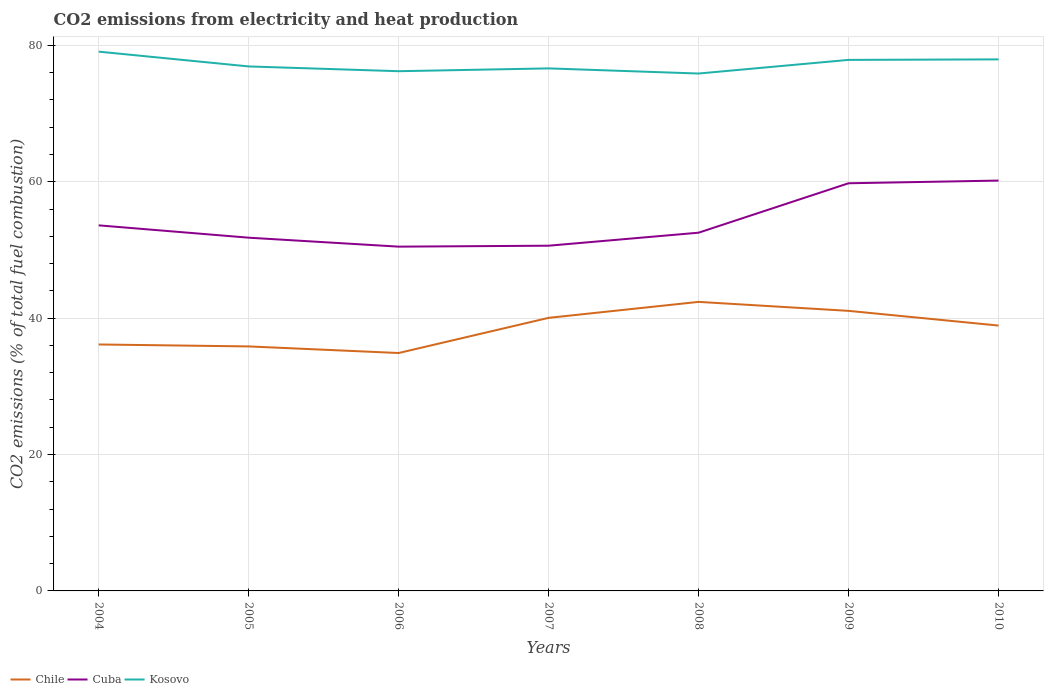How many different coloured lines are there?
Give a very brief answer. 3. Is the number of lines equal to the number of legend labels?
Ensure brevity in your answer.  Yes. Across all years, what is the maximum amount of CO2 emitted in Cuba?
Provide a short and direct response. 50.49. In which year was the amount of CO2 emitted in Cuba maximum?
Provide a succinct answer. 2006. What is the total amount of CO2 emitted in Chile in the graph?
Provide a short and direct response. 2.16. What is the difference between the highest and the second highest amount of CO2 emitted in Kosovo?
Your answer should be compact. 3.21. How many lines are there?
Provide a short and direct response. 3. Does the graph contain any zero values?
Keep it short and to the point. No. Does the graph contain grids?
Provide a short and direct response. Yes. How many legend labels are there?
Ensure brevity in your answer.  3. What is the title of the graph?
Your response must be concise. CO2 emissions from electricity and heat production. Does "Albania" appear as one of the legend labels in the graph?
Provide a short and direct response. No. What is the label or title of the Y-axis?
Keep it short and to the point. CO2 emissions (% of total fuel combustion). What is the CO2 emissions (% of total fuel combustion) of Chile in 2004?
Ensure brevity in your answer.  36.14. What is the CO2 emissions (% of total fuel combustion) in Cuba in 2004?
Your response must be concise. 53.61. What is the CO2 emissions (% of total fuel combustion) of Kosovo in 2004?
Keep it short and to the point. 79.08. What is the CO2 emissions (% of total fuel combustion) in Chile in 2005?
Your answer should be compact. 35.85. What is the CO2 emissions (% of total fuel combustion) in Cuba in 2005?
Make the answer very short. 51.8. What is the CO2 emissions (% of total fuel combustion) of Kosovo in 2005?
Give a very brief answer. 76.91. What is the CO2 emissions (% of total fuel combustion) of Chile in 2006?
Give a very brief answer. 34.89. What is the CO2 emissions (% of total fuel combustion) of Cuba in 2006?
Offer a terse response. 50.49. What is the CO2 emissions (% of total fuel combustion) of Kosovo in 2006?
Give a very brief answer. 76.21. What is the CO2 emissions (% of total fuel combustion) in Chile in 2007?
Offer a very short reply. 40.04. What is the CO2 emissions (% of total fuel combustion) of Cuba in 2007?
Offer a very short reply. 50.62. What is the CO2 emissions (% of total fuel combustion) in Kosovo in 2007?
Make the answer very short. 76.62. What is the CO2 emissions (% of total fuel combustion) in Chile in 2008?
Give a very brief answer. 42.38. What is the CO2 emissions (% of total fuel combustion) of Cuba in 2008?
Make the answer very short. 52.53. What is the CO2 emissions (% of total fuel combustion) of Kosovo in 2008?
Offer a very short reply. 75.87. What is the CO2 emissions (% of total fuel combustion) in Chile in 2009?
Make the answer very short. 41.07. What is the CO2 emissions (% of total fuel combustion) of Cuba in 2009?
Keep it short and to the point. 59.78. What is the CO2 emissions (% of total fuel combustion) in Kosovo in 2009?
Make the answer very short. 77.87. What is the CO2 emissions (% of total fuel combustion) of Chile in 2010?
Provide a short and direct response. 38.91. What is the CO2 emissions (% of total fuel combustion) of Cuba in 2010?
Your answer should be very brief. 60.17. What is the CO2 emissions (% of total fuel combustion) in Kosovo in 2010?
Offer a very short reply. 77.95. Across all years, what is the maximum CO2 emissions (% of total fuel combustion) of Chile?
Give a very brief answer. 42.38. Across all years, what is the maximum CO2 emissions (% of total fuel combustion) in Cuba?
Provide a short and direct response. 60.17. Across all years, what is the maximum CO2 emissions (% of total fuel combustion) of Kosovo?
Ensure brevity in your answer.  79.08. Across all years, what is the minimum CO2 emissions (% of total fuel combustion) in Chile?
Your response must be concise. 34.89. Across all years, what is the minimum CO2 emissions (% of total fuel combustion) in Cuba?
Keep it short and to the point. 50.49. Across all years, what is the minimum CO2 emissions (% of total fuel combustion) of Kosovo?
Offer a terse response. 75.87. What is the total CO2 emissions (% of total fuel combustion) of Chile in the graph?
Your answer should be compact. 269.29. What is the total CO2 emissions (% of total fuel combustion) in Cuba in the graph?
Ensure brevity in your answer.  379. What is the total CO2 emissions (% of total fuel combustion) of Kosovo in the graph?
Offer a terse response. 540.52. What is the difference between the CO2 emissions (% of total fuel combustion) in Chile in 2004 and that in 2005?
Ensure brevity in your answer.  0.29. What is the difference between the CO2 emissions (% of total fuel combustion) in Cuba in 2004 and that in 2005?
Give a very brief answer. 1.81. What is the difference between the CO2 emissions (% of total fuel combustion) in Kosovo in 2004 and that in 2005?
Provide a succinct answer. 2.17. What is the difference between the CO2 emissions (% of total fuel combustion) of Chile in 2004 and that in 2006?
Provide a succinct answer. 1.25. What is the difference between the CO2 emissions (% of total fuel combustion) in Cuba in 2004 and that in 2006?
Your response must be concise. 3.12. What is the difference between the CO2 emissions (% of total fuel combustion) of Kosovo in 2004 and that in 2006?
Give a very brief answer. 2.87. What is the difference between the CO2 emissions (% of total fuel combustion) in Chile in 2004 and that in 2007?
Keep it short and to the point. -3.9. What is the difference between the CO2 emissions (% of total fuel combustion) of Cuba in 2004 and that in 2007?
Ensure brevity in your answer.  2.98. What is the difference between the CO2 emissions (% of total fuel combustion) in Kosovo in 2004 and that in 2007?
Ensure brevity in your answer.  2.46. What is the difference between the CO2 emissions (% of total fuel combustion) of Chile in 2004 and that in 2008?
Your response must be concise. -6.24. What is the difference between the CO2 emissions (% of total fuel combustion) of Cuba in 2004 and that in 2008?
Give a very brief answer. 1.08. What is the difference between the CO2 emissions (% of total fuel combustion) in Kosovo in 2004 and that in 2008?
Keep it short and to the point. 3.21. What is the difference between the CO2 emissions (% of total fuel combustion) of Chile in 2004 and that in 2009?
Your answer should be very brief. -4.93. What is the difference between the CO2 emissions (% of total fuel combustion) in Cuba in 2004 and that in 2009?
Provide a succinct answer. -6.17. What is the difference between the CO2 emissions (% of total fuel combustion) in Kosovo in 2004 and that in 2009?
Give a very brief answer. 1.21. What is the difference between the CO2 emissions (% of total fuel combustion) in Chile in 2004 and that in 2010?
Offer a very short reply. -2.77. What is the difference between the CO2 emissions (% of total fuel combustion) of Cuba in 2004 and that in 2010?
Make the answer very short. -6.57. What is the difference between the CO2 emissions (% of total fuel combustion) of Kosovo in 2004 and that in 2010?
Keep it short and to the point. 1.13. What is the difference between the CO2 emissions (% of total fuel combustion) in Cuba in 2005 and that in 2006?
Your answer should be compact. 1.31. What is the difference between the CO2 emissions (% of total fuel combustion) in Kosovo in 2005 and that in 2006?
Provide a short and direct response. 0.7. What is the difference between the CO2 emissions (% of total fuel combustion) in Chile in 2005 and that in 2007?
Provide a succinct answer. -4.19. What is the difference between the CO2 emissions (% of total fuel combustion) in Cuba in 2005 and that in 2007?
Give a very brief answer. 1.18. What is the difference between the CO2 emissions (% of total fuel combustion) in Kosovo in 2005 and that in 2007?
Provide a succinct answer. 0.29. What is the difference between the CO2 emissions (% of total fuel combustion) in Chile in 2005 and that in 2008?
Offer a terse response. -6.53. What is the difference between the CO2 emissions (% of total fuel combustion) in Cuba in 2005 and that in 2008?
Offer a very short reply. -0.73. What is the difference between the CO2 emissions (% of total fuel combustion) in Kosovo in 2005 and that in 2008?
Provide a short and direct response. 1.04. What is the difference between the CO2 emissions (% of total fuel combustion) in Chile in 2005 and that in 2009?
Provide a short and direct response. -5.21. What is the difference between the CO2 emissions (% of total fuel combustion) of Cuba in 2005 and that in 2009?
Provide a short and direct response. -7.98. What is the difference between the CO2 emissions (% of total fuel combustion) of Kosovo in 2005 and that in 2009?
Give a very brief answer. -0.96. What is the difference between the CO2 emissions (% of total fuel combustion) of Chile in 2005 and that in 2010?
Make the answer very short. -3.06. What is the difference between the CO2 emissions (% of total fuel combustion) of Cuba in 2005 and that in 2010?
Provide a succinct answer. -8.37. What is the difference between the CO2 emissions (% of total fuel combustion) in Kosovo in 2005 and that in 2010?
Keep it short and to the point. -1.03. What is the difference between the CO2 emissions (% of total fuel combustion) in Chile in 2006 and that in 2007?
Your answer should be compact. -5.16. What is the difference between the CO2 emissions (% of total fuel combustion) of Cuba in 2006 and that in 2007?
Ensure brevity in your answer.  -0.14. What is the difference between the CO2 emissions (% of total fuel combustion) in Kosovo in 2006 and that in 2007?
Provide a succinct answer. -0.41. What is the difference between the CO2 emissions (% of total fuel combustion) of Chile in 2006 and that in 2008?
Offer a terse response. -7.5. What is the difference between the CO2 emissions (% of total fuel combustion) of Cuba in 2006 and that in 2008?
Give a very brief answer. -2.04. What is the difference between the CO2 emissions (% of total fuel combustion) of Kosovo in 2006 and that in 2008?
Provide a short and direct response. 0.34. What is the difference between the CO2 emissions (% of total fuel combustion) of Chile in 2006 and that in 2009?
Provide a succinct answer. -6.18. What is the difference between the CO2 emissions (% of total fuel combustion) in Cuba in 2006 and that in 2009?
Provide a succinct answer. -9.29. What is the difference between the CO2 emissions (% of total fuel combustion) of Kosovo in 2006 and that in 2009?
Your response must be concise. -1.66. What is the difference between the CO2 emissions (% of total fuel combustion) in Chile in 2006 and that in 2010?
Offer a terse response. -4.03. What is the difference between the CO2 emissions (% of total fuel combustion) of Cuba in 2006 and that in 2010?
Offer a terse response. -9.69. What is the difference between the CO2 emissions (% of total fuel combustion) of Kosovo in 2006 and that in 2010?
Provide a short and direct response. -1.73. What is the difference between the CO2 emissions (% of total fuel combustion) of Chile in 2007 and that in 2008?
Keep it short and to the point. -2.34. What is the difference between the CO2 emissions (% of total fuel combustion) in Cuba in 2007 and that in 2008?
Make the answer very short. -1.91. What is the difference between the CO2 emissions (% of total fuel combustion) in Kosovo in 2007 and that in 2008?
Provide a succinct answer. 0.75. What is the difference between the CO2 emissions (% of total fuel combustion) in Chile in 2007 and that in 2009?
Offer a terse response. -1.03. What is the difference between the CO2 emissions (% of total fuel combustion) in Cuba in 2007 and that in 2009?
Offer a terse response. -9.16. What is the difference between the CO2 emissions (% of total fuel combustion) in Kosovo in 2007 and that in 2009?
Offer a terse response. -1.25. What is the difference between the CO2 emissions (% of total fuel combustion) of Chile in 2007 and that in 2010?
Your answer should be very brief. 1.13. What is the difference between the CO2 emissions (% of total fuel combustion) of Cuba in 2007 and that in 2010?
Your answer should be very brief. -9.55. What is the difference between the CO2 emissions (% of total fuel combustion) in Kosovo in 2007 and that in 2010?
Provide a short and direct response. -1.32. What is the difference between the CO2 emissions (% of total fuel combustion) of Chile in 2008 and that in 2009?
Ensure brevity in your answer.  1.32. What is the difference between the CO2 emissions (% of total fuel combustion) in Cuba in 2008 and that in 2009?
Ensure brevity in your answer.  -7.25. What is the difference between the CO2 emissions (% of total fuel combustion) of Kosovo in 2008 and that in 2009?
Ensure brevity in your answer.  -2. What is the difference between the CO2 emissions (% of total fuel combustion) in Chile in 2008 and that in 2010?
Your answer should be compact. 3.47. What is the difference between the CO2 emissions (% of total fuel combustion) in Cuba in 2008 and that in 2010?
Your answer should be compact. -7.64. What is the difference between the CO2 emissions (% of total fuel combustion) of Kosovo in 2008 and that in 2010?
Offer a very short reply. -2.08. What is the difference between the CO2 emissions (% of total fuel combustion) of Chile in 2009 and that in 2010?
Your response must be concise. 2.16. What is the difference between the CO2 emissions (% of total fuel combustion) in Cuba in 2009 and that in 2010?
Your answer should be very brief. -0.4. What is the difference between the CO2 emissions (% of total fuel combustion) in Kosovo in 2009 and that in 2010?
Make the answer very short. -0.07. What is the difference between the CO2 emissions (% of total fuel combustion) of Chile in 2004 and the CO2 emissions (% of total fuel combustion) of Cuba in 2005?
Offer a terse response. -15.66. What is the difference between the CO2 emissions (% of total fuel combustion) of Chile in 2004 and the CO2 emissions (% of total fuel combustion) of Kosovo in 2005?
Ensure brevity in your answer.  -40.77. What is the difference between the CO2 emissions (% of total fuel combustion) in Cuba in 2004 and the CO2 emissions (% of total fuel combustion) in Kosovo in 2005?
Provide a short and direct response. -23.3. What is the difference between the CO2 emissions (% of total fuel combustion) in Chile in 2004 and the CO2 emissions (% of total fuel combustion) in Cuba in 2006?
Offer a terse response. -14.35. What is the difference between the CO2 emissions (% of total fuel combustion) in Chile in 2004 and the CO2 emissions (% of total fuel combustion) in Kosovo in 2006?
Provide a short and direct response. -40.07. What is the difference between the CO2 emissions (% of total fuel combustion) of Cuba in 2004 and the CO2 emissions (% of total fuel combustion) of Kosovo in 2006?
Offer a very short reply. -22.6. What is the difference between the CO2 emissions (% of total fuel combustion) in Chile in 2004 and the CO2 emissions (% of total fuel combustion) in Cuba in 2007?
Provide a succinct answer. -14.48. What is the difference between the CO2 emissions (% of total fuel combustion) in Chile in 2004 and the CO2 emissions (% of total fuel combustion) in Kosovo in 2007?
Your response must be concise. -40.48. What is the difference between the CO2 emissions (% of total fuel combustion) of Cuba in 2004 and the CO2 emissions (% of total fuel combustion) of Kosovo in 2007?
Your response must be concise. -23.02. What is the difference between the CO2 emissions (% of total fuel combustion) of Chile in 2004 and the CO2 emissions (% of total fuel combustion) of Cuba in 2008?
Give a very brief answer. -16.39. What is the difference between the CO2 emissions (% of total fuel combustion) in Chile in 2004 and the CO2 emissions (% of total fuel combustion) in Kosovo in 2008?
Provide a short and direct response. -39.73. What is the difference between the CO2 emissions (% of total fuel combustion) in Cuba in 2004 and the CO2 emissions (% of total fuel combustion) in Kosovo in 2008?
Give a very brief answer. -22.26. What is the difference between the CO2 emissions (% of total fuel combustion) in Chile in 2004 and the CO2 emissions (% of total fuel combustion) in Cuba in 2009?
Your answer should be very brief. -23.64. What is the difference between the CO2 emissions (% of total fuel combustion) of Chile in 2004 and the CO2 emissions (% of total fuel combustion) of Kosovo in 2009?
Provide a short and direct response. -41.73. What is the difference between the CO2 emissions (% of total fuel combustion) of Cuba in 2004 and the CO2 emissions (% of total fuel combustion) of Kosovo in 2009?
Your answer should be compact. -24.26. What is the difference between the CO2 emissions (% of total fuel combustion) in Chile in 2004 and the CO2 emissions (% of total fuel combustion) in Cuba in 2010?
Your answer should be compact. -24.03. What is the difference between the CO2 emissions (% of total fuel combustion) in Chile in 2004 and the CO2 emissions (% of total fuel combustion) in Kosovo in 2010?
Provide a short and direct response. -41.81. What is the difference between the CO2 emissions (% of total fuel combustion) in Cuba in 2004 and the CO2 emissions (% of total fuel combustion) in Kosovo in 2010?
Make the answer very short. -24.34. What is the difference between the CO2 emissions (% of total fuel combustion) in Chile in 2005 and the CO2 emissions (% of total fuel combustion) in Cuba in 2006?
Offer a terse response. -14.63. What is the difference between the CO2 emissions (% of total fuel combustion) of Chile in 2005 and the CO2 emissions (% of total fuel combustion) of Kosovo in 2006?
Make the answer very short. -40.36. What is the difference between the CO2 emissions (% of total fuel combustion) of Cuba in 2005 and the CO2 emissions (% of total fuel combustion) of Kosovo in 2006?
Your response must be concise. -24.41. What is the difference between the CO2 emissions (% of total fuel combustion) of Chile in 2005 and the CO2 emissions (% of total fuel combustion) of Cuba in 2007?
Offer a terse response. -14.77. What is the difference between the CO2 emissions (% of total fuel combustion) of Chile in 2005 and the CO2 emissions (% of total fuel combustion) of Kosovo in 2007?
Keep it short and to the point. -40.77. What is the difference between the CO2 emissions (% of total fuel combustion) in Cuba in 2005 and the CO2 emissions (% of total fuel combustion) in Kosovo in 2007?
Your answer should be compact. -24.82. What is the difference between the CO2 emissions (% of total fuel combustion) of Chile in 2005 and the CO2 emissions (% of total fuel combustion) of Cuba in 2008?
Provide a succinct answer. -16.68. What is the difference between the CO2 emissions (% of total fuel combustion) of Chile in 2005 and the CO2 emissions (% of total fuel combustion) of Kosovo in 2008?
Make the answer very short. -40.02. What is the difference between the CO2 emissions (% of total fuel combustion) in Cuba in 2005 and the CO2 emissions (% of total fuel combustion) in Kosovo in 2008?
Provide a short and direct response. -24.07. What is the difference between the CO2 emissions (% of total fuel combustion) of Chile in 2005 and the CO2 emissions (% of total fuel combustion) of Cuba in 2009?
Your answer should be compact. -23.92. What is the difference between the CO2 emissions (% of total fuel combustion) in Chile in 2005 and the CO2 emissions (% of total fuel combustion) in Kosovo in 2009?
Your response must be concise. -42.02. What is the difference between the CO2 emissions (% of total fuel combustion) in Cuba in 2005 and the CO2 emissions (% of total fuel combustion) in Kosovo in 2009?
Give a very brief answer. -26.07. What is the difference between the CO2 emissions (% of total fuel combustion) of Chile in 2005 and the CO2 emissions (% of total fuel combustion) of Cuba in 2010?
Your answer should be compact. -24.32. What is the difference between the CO2 emissions (% of total fuel combustion) of Chile in 2005 and the CO2 emissions (% of total fuel combustion) of Kosovo in 2010?
Your response must be concise. -42.09. What is the difference between the CO2 emissions (% of total fuel combustion) of Cuba in 2005 and the CO2 emissions (% of total fuel combustion) of Kosovo in 2010?
Your answer should be compact. -26.15. What is the difference between the CO2 emissions (% of total fuel combustion) in Chile in 2006 and the CO2 emissions (% of total fuel combustion) in Cuba in 2007?
Your response must be concise. -15.74. What is the difference between the CO2 emissions (% of total fuel combustion) in Chile in 2006 and the CO2 emissions (% of total fuel combustion) in Kosovo in 2007?
Offer a terse response. -41.74. What is the difference between the CO2 emissions (% of total fuel combustion) in Cuba in 2006 and the CO2 emissions (% of total fuel combustion) in Kosovo in 2007?
Provide a short and direct response. -26.14. What is the difference between the CO2 emissions (% of total fuel combustion) in Chile in 2006 and the CO2 emissions (% of total fuel combustion) in Cuba in 2008?
Make the answer very short. -17.64. What is the difference between the CO2 emissions (% of total fuel combustion) in Chile in 2006 and the CO2 emissions (% of total fuel combustion) in Kosovo in 2008?
Offer a very short reply. -40.98. What is the difference between the CO2 emissions (% of total fuel combustion) in Cuba in 2006 and the CO2 emissions (% of total fuel combustion) in Kosovo in 2008?
Your answer should be very brief. -25.39. What is the difference between the CO2 emissions (% of total fuel combustion) of Chile in 2006 and the CO2 emissions (% of total fuel combustion) of Cuba in 2009?
Make the answer very short. -24.89. What is the difference between the CO2 emissions (% of total fuel combustion) of Chile in 2006 and the CO2 emissions (% of total fuel combustion) of Kosovo in 2009?
Make the answer very short. -42.98. What is the difference between the CO2 emissions (% of total fuel combustion) in Cuba in 2006 and the CO2 emissions (% of total fuel combustion) in Kosovo in 2009?
Provide a succinct answer. -27.39. What is the difference between the CO2 emissions (% of total fuel combustion) of Chile in 2006 and the CO2 emissions (% of total fuel combustion) of Cuba in 2010?
Keep it short and to the point. -25.29. What is the difference between the CO2 emissions (% of total fuel combustion) in Chile in 2006 and the CO2 emissions (% of total fuel combustion) in Kosovo in 2010?
Make the answer very short. -43.06. What is the difference between the CO2 emissions (% of total fuel combustion) in Cuba in 2006 and the CO2 emissions (% of total fuel combustion) in Kosovo in 2010?
Your response must be concise. -27.46. What is the difference between the CO2 emissions (% of total fuel combustion) in Chile in 2007 and the CO2 emissions (% of total fuel combustion) in Cuba in 2008?
Make the answer very short. -12.49. What is the difference between the CO2 emissions (% of total fuel combustion) in Chile in 2007 and the CO2 emissions (% of total fuel combustion) in Kosovo in 2008?
Provide a succinct answer. -35.83. What is the difference between the CO2 emissions (% of total fuel combustion) in Cuba in 2007 and the CO2 emissions (% of total fuel combustion) in Kosovo in 2008?
Provide a short and direct response. -25.25. What is the difference between the CO2 emissions (% of total fuel combustion) in Chile in 2007 and the CO2 emissions (% of total fuel combustion) in Cuba in 2009?
Provide a short and direct response. -19.74. What is the difference between the CO2 emissions (% of total fuel combustion) of Chile in 2007 and the CO2 emissions (% of total fuel combustion) of Kosovo in 2009?
Provide a succinct answer. -37.83. What is the difference between the CO2 emissions (% of total fuel combustion) of Cuba in 2007 and the CO2 emissions (% of total fuel combustion) of Kosovo in 2009?
Provide a succinct answer. -27.25. What is the difference between the CO2 emissions (% of total fuel combustion) of Chile in 2007 and the CO2 emissions (% of total fuel combustion) of Cuba in 2010?
Your answer should be very brief. -20.13. What is the difference between the CO2 emissions (% of total fuel combustion) of Chile in 2007 and the CO2 emissions (% of total fuel combustion) of Kosovo in 2010?
Make the answer very short. -37.9. What is the difference between the CO2 emissions (% of total fuel combustion) in Cuba in 2007 and the CO2 emissions (% of total fuel combustion) in Kosovo in 2010?
Your answer should be compact. -27.32. What is the difference between the CO2 emissions (% of total fuel combustion) of Chile in 2008 and the CO2 emissions (% of total fuel combustion) of Cuba in 2009?
Provide a succinct answer. -17.39. What is the difference between the CO2 emissions (% of total fuel combustion) in Chile in 2008 and the CO2 emissions (% of total fuel combustion) in Kosovo in 2009?
Your answer should be compact. -35.49. What is the difference between the CO2 emissions (% of total fuel combustion) in Cuba in 2008 and the CO2 emissions (% of total fuel combustion) in Kosovo in 2009?
Make the answer very short. -25.34. What is the difference between the CO2 emissions (% of total fuel combustion) in Chile in 2008 and the CO2 emissions (% of total fuel combustion) in Cuba in 2010?
Ensure brevity in your answer.  -17.79. What is the difference between the CO2 emissions (% of total fuel combustion) of Chile in 2008 and the CO2 emissions (% of total fuel combustion) of Kosovo in 2010?
Your answer should be very brief. -35.56. What is the difference between the CO2 emissions (% of total fuel combustion) of Cuba in 2008 and the CO2 emissions (% of total fuel combustion) of Kosovo in 2010?
Provide a short and direct response. -25.42. What is the difference between the CO2 emissions (% of total fuel combustion) of Chile in 2009 and the CO2 emissions (% of total fuel combustion) of Cuba in 2010?
Make the answer very short. -19.1. What is the difference between the CO2 emissions (% of total fuel combustion) of Chile in 2009 and the CO2 emissions (% of total fuel combustion) of Kosovo in 2010?
Make the answer very short. -36.88. What is the difference between the CO2 emissions (% of total fuel combustion) in Cuba in 2009 and the CO2 emissions (% of total fuel combustion) in Kosovo in 2010?
Make the answer very short. -18.17. What is the average CO2 emissions (% of total fuel combustion) in Chile per year?
Your answer should be compact. 38.47. What is the average CO2 emissions (% of total fuel combustion) of Cuba per year?
Keep it short and to the point. 54.14. What is the average CO2 emissions (% of total fuel combustion) in Kosovo per year?
Make the answer very short. 77.22. In the year 2004, what is the difference between the CO2 emissions (% of total fuel combustion) of Chile and CO2 emissions (% of total fuel combustion) of Cuba?
Offer a very short reply. -17.47. In the year 2004, what is the difference between the CO2 emissions (% of total fuel combustion) of Chile and CO2 emissions (% of total fuel combustion) of Kosovo?
Your response must be concise. -42.94. In the year 2004, what is the difference between the CO2 emissions (% of total fuel combustion) of Cuba and CO2 emissions (% of total fuel combustion) of Kosovo?
Provide a short and direct response. -25.47. In the year 2005, what is the difference between the CO2 emissions (% of total fuel combustion) in Chile and CO2 emissions (% of total fuel combustion) in Cuba?
Keep it short and to the point. -15.94. In the year 2005, what is the difference between the CO2 emissions (% of total fuel combustion) of Chile and CO2 emissions (% of total fuel combustion) of Kosovo?
Make the answer very short. -41.06. In the year 2005, what is the difference between the CO2 emissions (% of total fuel combustion) of Cuba and CO2 emissions (% of total fuel combustion) of Kosovo?
Provide a succinct answer. -25.11. In the year 2006, what is the difference between the CO2 emissions (% of total fuel combustion) of Chile and CO2 emissions (% of total fuel combustion) of Cuba?
Your answer should be compact. -15.6. In the year 2006, what is the difference between the CO2 emissions (% of total fuel combustion) in Chile and CO2 emissions (% of total fuel combustion) in Kosovo?
Your answer should be very brief. -41.32. In the year 2006, what is the difference between the CO2 emissions (% of total fuel combustion) in Cuba and CO2 emissions (% of total fuel combustion) in Kosovo?
Ensure brevity in your answer.  -25.73. In the year 2007, what is the difference between the CO2 emissions (% of total fuel combustion) of Chile and CO2 emissions (% of total fuel combustion) of Cuba?
Offer a terse response. -10.58. In the year 2007, what is the difference between the CO2 emissions (% of total fuel combustion) in Chile and CO2 emissions (% of total fuel combustion) in Kosovo?
Your response must be concise. -36.58. In the year 2007, what is the difference between the CO2 emissions (% of total fuel combustion) in Cuba and CO2 emissions (% of total fuel combustion) in Kosovo?
Your answer should be compact. -26. In the year 2008, what is the difference between the CO2 emissions (% of total fuel combustion) of Chile and CO2 emissions (% of total fuel combustion) of Cuba?
Ensure brevity in your answer.  -10.15. In the year 2008, what is the difference between the CO2 emissions (% of total fuel combustion) of Chile and CO2 emissions (% of total fuel combustion) of Kosovo?
Give a very brief answer. -33.49. In the year 2008, what is the difference between the CO2 emissions (% of total fuel combustion) of Cuba and CO2 emissions (% of total fuel combustion) of Kosovo?
Offer a very short reply. -23.34. In the year 2009, what is the difference between the CO2 emissions (% of total fuel combustion) in Chile and CO2 emissions (% of total fuel combustion) in Cuba?
Your answer should be very brief. -18.71. In the year 2009, what is the difference between the CO2 emissions (% of total fuel combustion) in Chile and CO2 emissions (% of total fuel combustion) in Kosovo?
Offer a very short reply. -36.8. In the year 2009, what is the difference between the CO2 emissions (% of total fuel combustion) of Cuba and CO2 emissions (% of total fuel combustion) of Kosovo?
Offer a terse response. -18.09. In the year 2010, what is the difference between the CO2 emissions (% of total fuel combustion) in Chile and CO2 emissions (% of total fuel combustion) in Cuba?
Make the answer very short. -21.26. In the year 2010, what is the difference between the CO2 emissions (% of total fuel combustion) of Chile and CO2 emissions (% of total fuel combustion) of Kosovo?
Your response must be concise. -39.03. In the year 2010, what is the difference between the CO2 emissions (% of total fuel combustion) in Cuba and CO2 emissions (% of total fuel combustion) in Kosovo?
Your response must be concise. -17.77. What is the ratio of the CO2 emissions (% of total fuel combustion) of Chile in 2004 to that in 2005?
Make the answer very short. 1.01. What is the ratio of the CO2 emissions (% of total fuel combustion) in Cuba in 2004 to that in 2005?
Offer a terse response. 1.03. What is the ratio of the CO2 emissions (% of total fuel combustion) of Kosovo in 2004 to that in 2005?
Keep it short and to the point. 1.03. What is the ratio of the CO2 emissions (% of total fuel combustion) in Chile in 2004 to that in 2006?
Your answer should be compact. 1.04. What is the ratio of the CO2 emissions (% of total fuel combustion) of Cuba in 2004 to that in 2006?
Your response must be concise. 1.06. What is the ratio of the CO2 emissions (% of total fuel combustion) in Kosovo in 2004 to that in 2006?
Make the answer very short. 1.04. What is the ratio of the CO2 emissions (% of total fuel combustion) of Chile in 2004 to that in 2007?
Your response must be concise. 0.9. What is the ratio of the CO2 emissions (% of total fuel combustion) of Cuba in 2004 to that in 2007?
Keep it short and to the point. 1.06. What is the ratio of the CO2 emissions (% of total fuel combustion) in Kosovo in 2004 to that in 2007?
Provide a succinct answer. 1.03. What is the ratio of the CO2 emissions (% of total fuel combustion) in Chile in 2004 to that in 2008?
Provide a short and direct response. 0.85. What is the ratio of the CO2 emissions (% of total fuel combustion) in Cuba in 2004 to that in 2008?
Make the answer very short. 1.02. What is the ratio of the CO2 emissions (% of total fuel combustion) of Kosovo in 2004 to that in 2008?
Keep it short and to the point. 1.04. What is the ratio of the CO2 emissions (% of total fuel combustion) in Chile in 2004 to that in 2009?
Provide a short and direct response. 0.88. What is the ratio of the CO2 emissions (% of total fuel combustion) in Cuba in 2004 to that in 2009?
Provide a short and direct response. 0.9. What is the ratio of the CO2 emissions (% of total fuel combustion) of Kosovo in 2004 to that in 2009?
Offer a terse response. 1.02. What is the ratio of the CO2 emissions (% of total fuel combustion) in Chile in 2004 to that in 2010?
Give a very brief answer. 0.93. What is the ratio of the CO2 emissions (% of total fuel combustion) in Cuba in 2004 to that in 2010?
Your response must be concise. 0.89. What is the ratio of the CO2 emissions (% of total fuel combustion) of Kosovo in 2004 to that in 2010?
Offer a very short reply. 1.01. What is the ratio of the CO2 emissions (% of total fuel combustion) of Chile in 2005 to that in 2006?
Offer a very short reply. 1.03. What is the ratio of the CO2 emissions (% of total fuel combustion) of Cuba in 2005 to that in 2006?
Your answer should be very brief. 1.03. What is the ratio of the CO2 emissions (% of total fuel combustion) in Kosovo in 2005 to that in 2006?
Your response must be concise. 1.01. What is the ratio of the CO2 emissions (% of total fuel combustion) of Chile in 2005 to that in 2007?
Provide a short and direct response. 0.9. What is the ratio of the CO2 emissions (% of total fuel combustion) of Cuba in 2005 to that in 2007?
Offer a very short reply. 1.02. What is the ratio of the CO2 emissions (% of total fuel combustion) of Kosovo in 2005 to that in 2007?
Offer a very short reply. 1. What is the ratio of the CO2 emissions (% of total fuel combustion) in Chile in 2005 to that in 2008?
Your answer should be compact. 0.85. What is the ratio of the CO2 emissions (% of total fuel combustion) in Cuba in 2005 to that in 2008?
Keep it short and to the point. 0.99. What is the ratio of the CO2 emissions (% of total fuel combustion) in Kosovo in 2005 to that in 2008?
Give a very brief answer. 1.01. What is the ratio of the CO2 emissions (% of total fuel combustion) in Chile in 2005 to that in 2009?
Keep it short and to the point. 0.87. What is the ratio of the CO2 emissions (% of total fuel combustion) of Cuba in 2005 to that in 2009?
Your response must be concise. 0.87. What is the ratio of the CO2 emissions (% of total fuel combustion) in Kosovo in 2005 to that in 2009?
Offer a terse response. 0.99. What is the ratio of the CO2 emissions (% of total fuel combustion) of Chile in 2005 to that in 2010?
Make the answer very short. 0.92. What is the ratio of the CO2 emissions (% of total fuel combustion) in Cuba in 2005 to that in 2010?
Make the answer very short. 0.86. What is the ratio of the CO2 emissions (% of total fuel combustion) of Kosovo in 2005 to that in 2010?
Ensure brevity in your answer.  0.99. What is the ratio of the CO2 emissions (% of total fuel combustion) of Chile in 2006 to that in 2007?
Make the answer very short. 0.87. What is the ratio of the CO2 emissions (% of total fuel combustion) in Kosovo in 2006 to that in 2007?
Keep it short and to the point. 0.99. What is the ratio of the CO2 emissions (% of total fuel combustion) in Chile in 2006 to that in 2008?
Your answer should be very brief. 0.82. What is the ratio of the CO2 emissions (% of total fuel combustion) of Cuba in 2006 to that in 2008?
Provide a succinct answer. 0.96. What is the ratio of the CO2 emissions (% of total fuel combustion) of Kosovo in 2006 to that in 2008?
Your answer should be very brief. 1. What is the ratio of the CO2 emissions (% of total fuel combustion) in Chile in 2006 to that in 2009?
Ensure brevity in your answer.  0.85. What is the ratio of the CO2 emissions (% of total fuel combustion) of Cuba in 2006 to that in 2009?
Your answer should be very brief. 0.84. What is the ratio of the CO2 emissions (% of total fuel combustion) of Kosovo in 2006 to that in 2009?
Offer a very short reply. 0.98. What is the ratio of the CO2 emissions (% of total fuel combustion) of Chile in 2006 to that in 2010?
Your answer should be compact. 0.9. What is the ratio of the CO2 emissions (% of total fuel combustion) of Cuba in 2006 to that in 2010?
Offer a terse response. 0.84. What is the ratio of the CO2 emissions (% of total fuel combustion) in Kosovo in 2006 to that in 2010?
Make the answer very short. 0.98. What is the ratio of the CO2 emissions (% of total fuel combustion) of Chile in 2007 to that in 2008?
Provide a short and direct response. 0.94. What is the ratio of the CO2 emissions (% of total fuel combustion) in Cuba in 2007 to that in 2008?
Keep it short and to the point. 0.96. What is the ratio of the CO2 emissions (% of total fuel combustion) in Kosovo in 2007 to that in 2008?
Make the answer very short. 1.01. What is the ratio of the CO2 emissions (% of total fuel combustion) of Cuba in 2007 to that in 2009?
Offer a terse response. 0.85. What is the ratio of the CO2 emissions (% of total fuel combustion) of Kosovo in 2007 to that in 2009?
Keep it short and to the point. 0.98. What is the ratio of the CO2 emissions (% of total fuel combustion) of Cuba in 2007 to that in 2010?
Offer a very short reply. 0.84. What is the ratio of the CO2 emissions (% of total fuel combustion) in Kosovo in 2007 to that in 2010?
Offer a very short reply. 0.98. What is the ratio of the CO2 emissions (% of total fuel combustion) of Chile in 2008 to that in 2009?
Make the answer very short. 1.03. What is the ratio of the CO2 emissions (% of total fuel combustion) of Cuba in 2008 to that in 2009?
Provide a succinct answer. 0.88. What is the ratio of the CO2 emissions (% of total fuel combustion) of Kosovo in 2008 to that in 2009?
Offer a terse response. 0.97. What is the ratio of the CO2 emissions (% of total fuel combustion) of Chile in 2008 to that in 2010?
Offer a terse response. 1.09. What is the ratio of the CO2 emissions (% of total fuel combustion) of Cuba in 2008 to that in 2010?
Your response must be concise. 0.87. What is the ratio of the CO2 emissions (% of total fuel combustion) in Kosovo in 2008 to that in 2010?
Your response must be concise. 0.97. What is the ratio of the CO2 emissions (% of total fuel combustion) in Chile in 2009 to that in 2010?
Provide a short and direct response. 1.06. What is the ratio of the CO2 emissions (% of total fuel combustion) of Cuba in 2009 to that in 2010?
Make the answer very short. 0.99. What is the difference between the highest and the second highest CO2 emissions (% of total fuel combustion) in Chile?
Your answer should be compact. 1.32. What is the difference between the highest and the second highest CO2 emissions (% of total fuel combustion) in Cuba?
Your response must be concise. 0.4. What is the difference between the highest and the second highest CO2 emissions (% of total fuel combustion) of Kosovo?
Your answer should be compact. 1.13. What is the difference between the highest and the lowest CO2 emissions (% of total fuel combustion) of Chile?
Ensure brevity in your answer.  7.5. What is the difference between the highest and the lowest CO2 emissions (% of total fuel combustion) in Cuba?
Your response must be concise. 9.69. What is the difference between the highest and the lowest CO2 emissions (% of total fuel combustion) in Kosovo?
Make the answer very short. 3.21. 